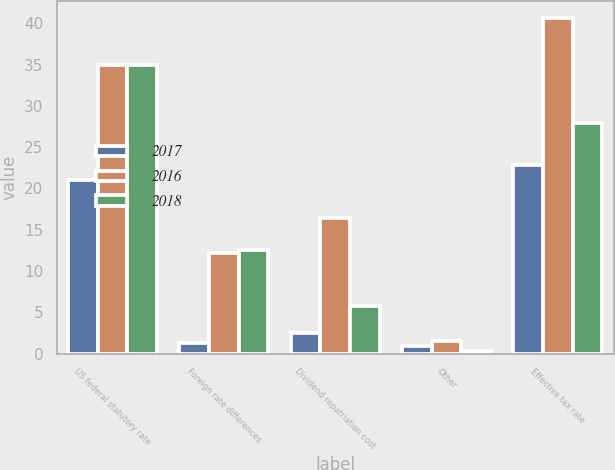Convert chart to OTSL. <chart><loc_0><loc_0><loc_500><loc_500><stacked_bar_chart><ecel><fcel>US federal statutory rate<fcel>Foreign rate differences<fcel>Dividend repatriation cost<fcel>Other<fcel>Effective tax rate<nl><fcel>2017<fcel>21<fcel>1.3<fcel>2.5<fcel>0.9<fcel>22.9<nl><fcel>2016<fcel>35<fcel>12.2<fcel>16.4<fcel>1.5<fcel>40.7<nl><fcel>2018<fcel>35<fcel>12.6<fcel>5.8<fcel>0.3<fcel>27.9<nl></chart> 